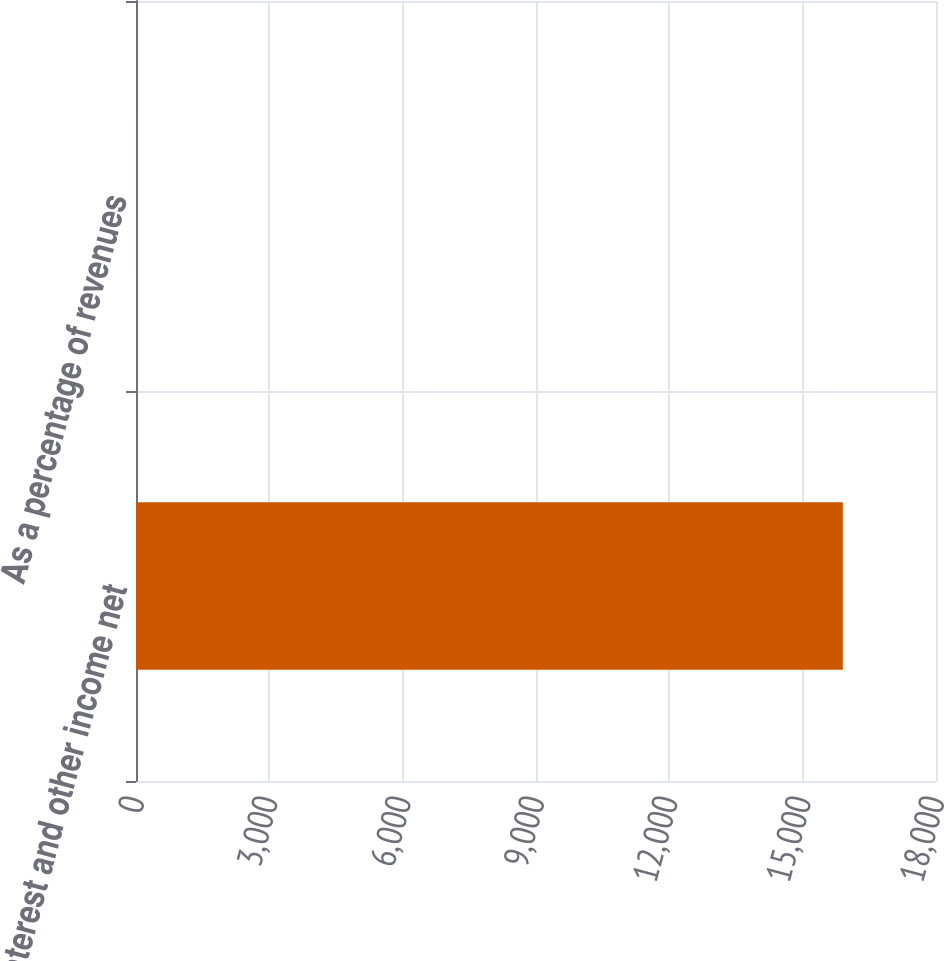<chart> <loc_0><loc_0><loc_500><loc_500><bar_chart><fcel>Interest and other income net<fcel>As a percentage of revenues<nl><fcel>15904<fcel>1.5<nl></chart> 